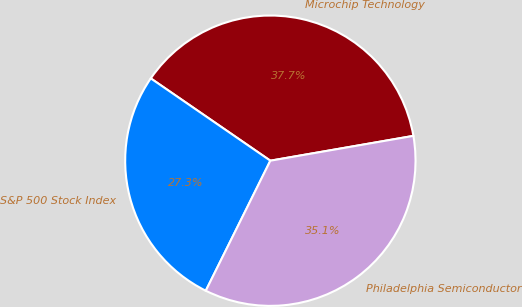Convert chart to OTSL. <chart><loc_0><loc_0><loc_500><loc_500><pie_chart><fcel>Microchip Technology<fcel>S&P 500 Stock Index<fcel>Philadelphia Semiconductor<nl><fcel>37.67%<fcel>27.26%<fcel>35.07%<nl></chart> 